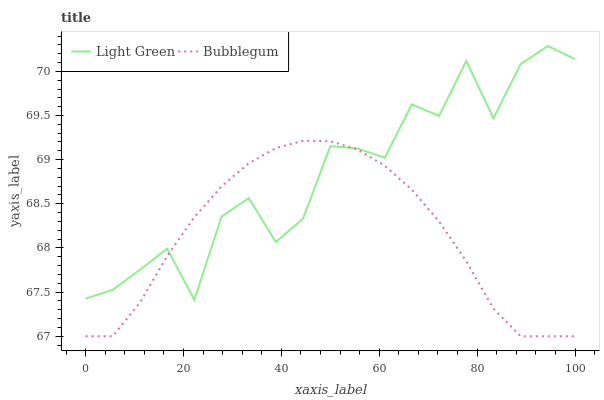Does Bubblegum have the minimum area under the curve?
Answer yes or no. Yes. Does Light Green have the maximum area under the curve?
Answer yes or no. Yes. Does Light Green have the minimum area under the curve?
Answer yes or no. No. Is Bubblegum the smoothest?
Answer yes or no. Yes. Is Light Green the roughest?
Answer yes or no. Yes. Is Light Green the smoothest?
Answer yes or no. No. Does Bubblegum have the lowest value?
Answer yes or no. Yes. Does Light Green have the lowest value?
Answer yes or no. No. Does Light Green have the highest value?
Answer yes or no. Yes. Does Bubblegum intersect Light Green?
Answer yes or no. Yes. Is Bubblegum less than Light Green?
Answer yes or no. No. Is Bubblegum greater than Light Green?
Answer yes or no. No. 